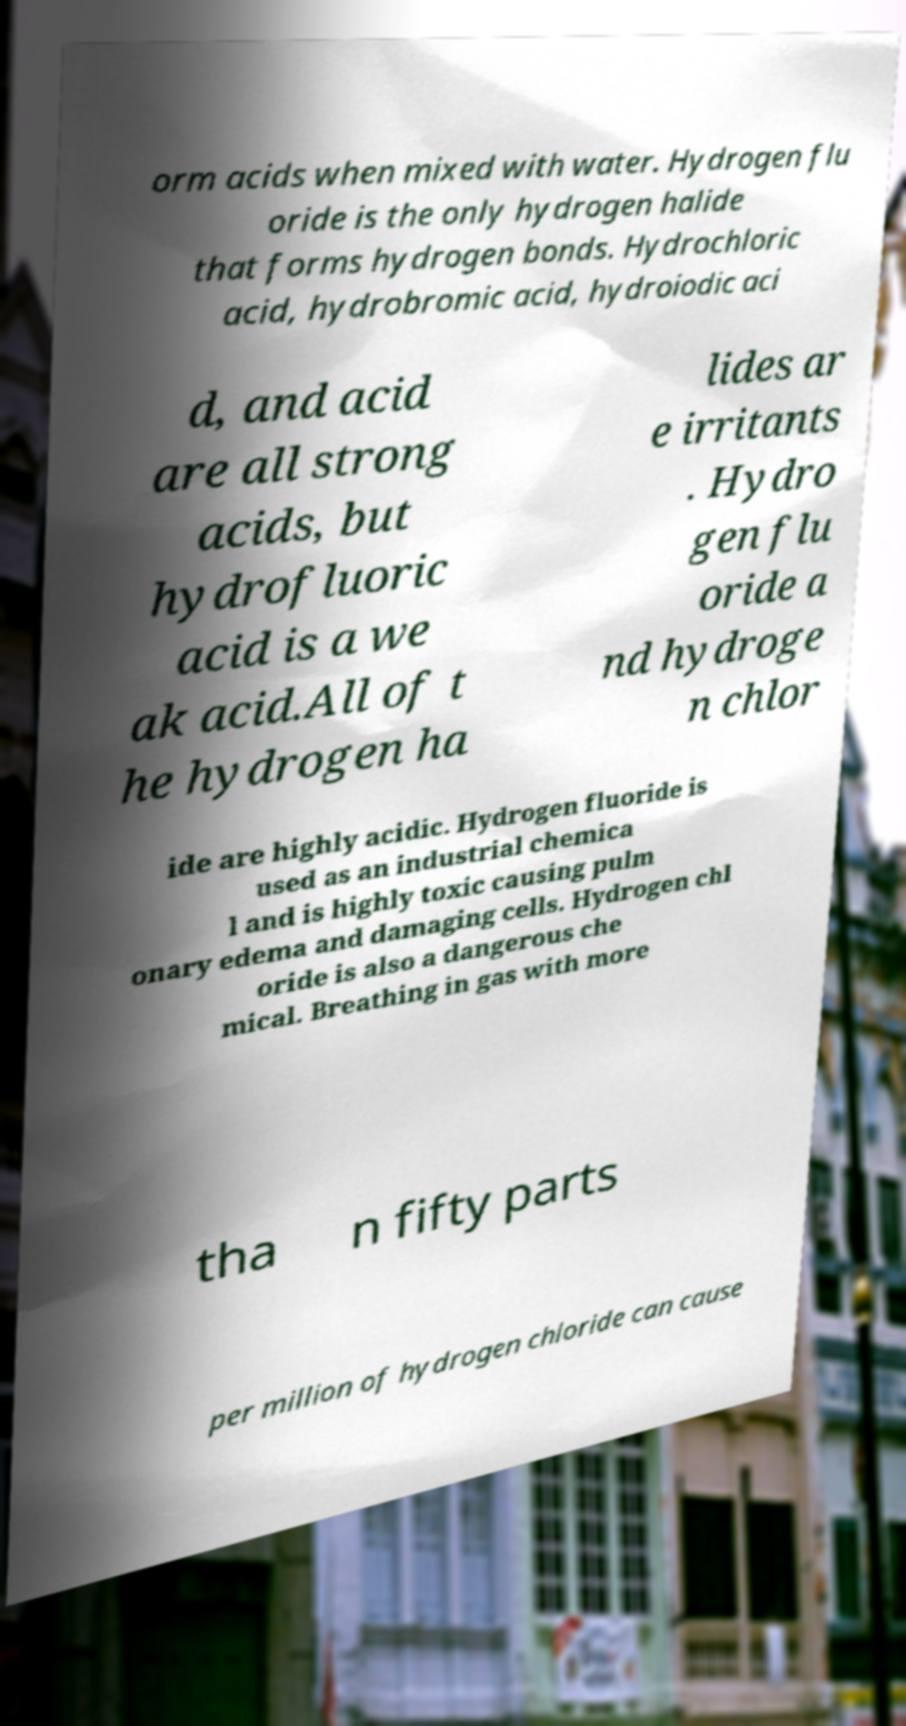Can you accurately transcribe the text from the provided image for me? orm acids when mixed with water. Hydrogen flu oride is the only hydrogen halide that forms hydrogen bonds. Hydrochloric acid, hydrobromic acid, hydroiodic aci d, and acid are all strong acids, but hydrofluoric acid is a we ak acid.All of t he hydrogen ha lides ar e irritants . Hydro gen flu oride a nd hydroge n chlor ide are highly acidic. Hydrogen fluoride is used as an industrial chemica l and is highly toxic causing pulm onary edema and damaging cells. Hydrogen chl oride is also a dangerous che mical. Breathing in gas with more tha n fifty parts per million of hydrogen chloride can cause 